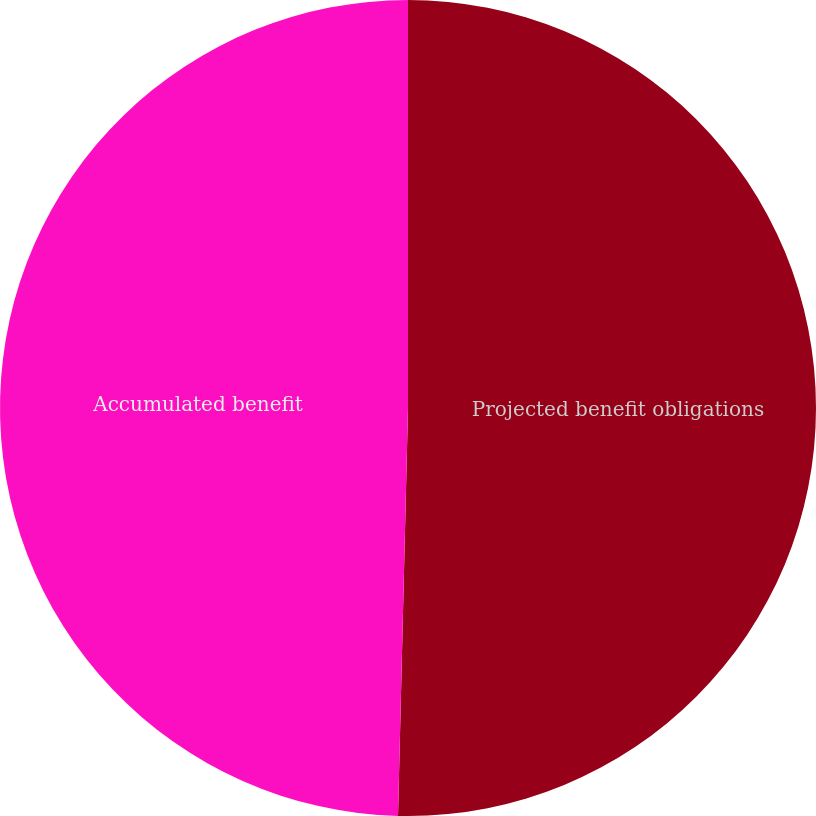<chart> <loc_0><loc_0><loc_500><loc_500><pie_chart><fcel>Projected benefit obligations<fcel>Accumulated benefit<nl><fcel>50.39%<fcel>49.61%<nl></chart> 